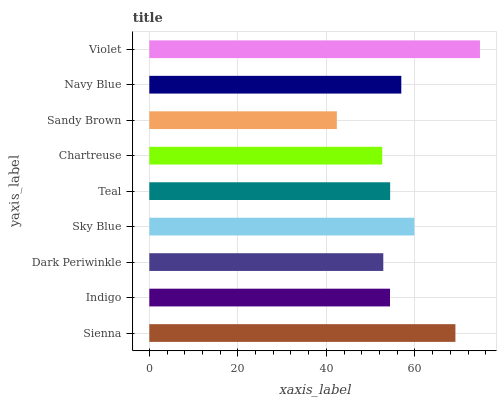Is Sandy Brown the minimum?
Answer yes or no. Yes. Is Violet the maximum?
Answer yes or no. Yes. Is Indigo the minimum?
Answer yes or no. No. Is Indigo the maximum?
Answer yes or no. No. Is Sienna greater than Indigo?
Answer yes or no. Yes. Is Indigo less than Sienna?
Answer yes or no. Yes. Is Indigo greater than Sienna?
Answer yes or no. No. Is Sienna less than Indigo?
Answer yes or no. No. Is Teal the high median?
Answer yes or no. Yes. Is Teal the low median?
Answer yes or no. Yes. Is Sienna the high median?
Answer yes or no. No. Is Violet the low median?
Answer yes or no. No. 